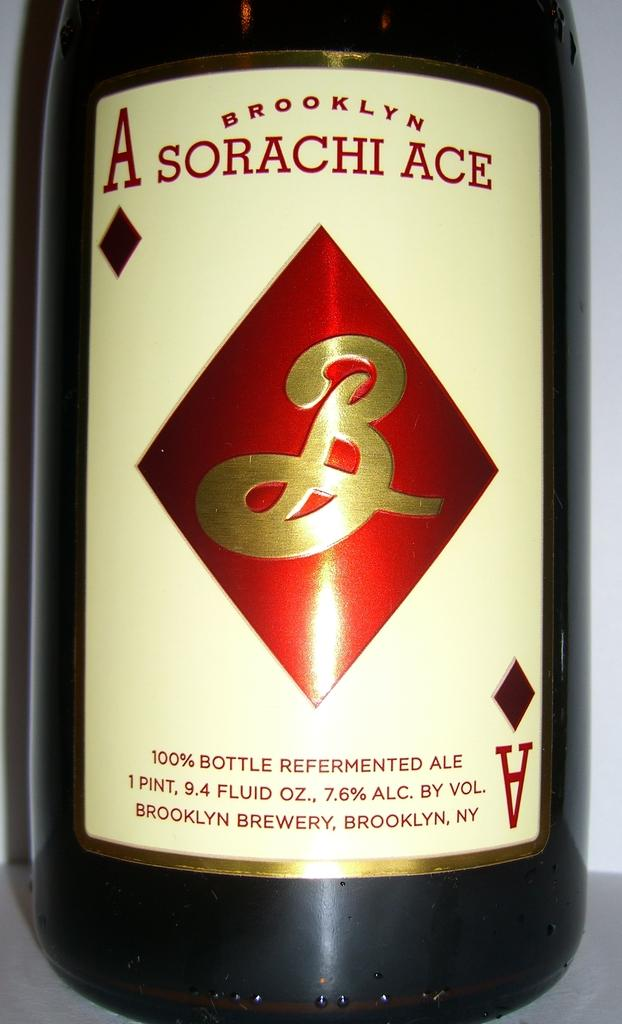Provide a one-sentence caption for the provided image. A bottle of Sorachi Ace Beer from New Yor. 